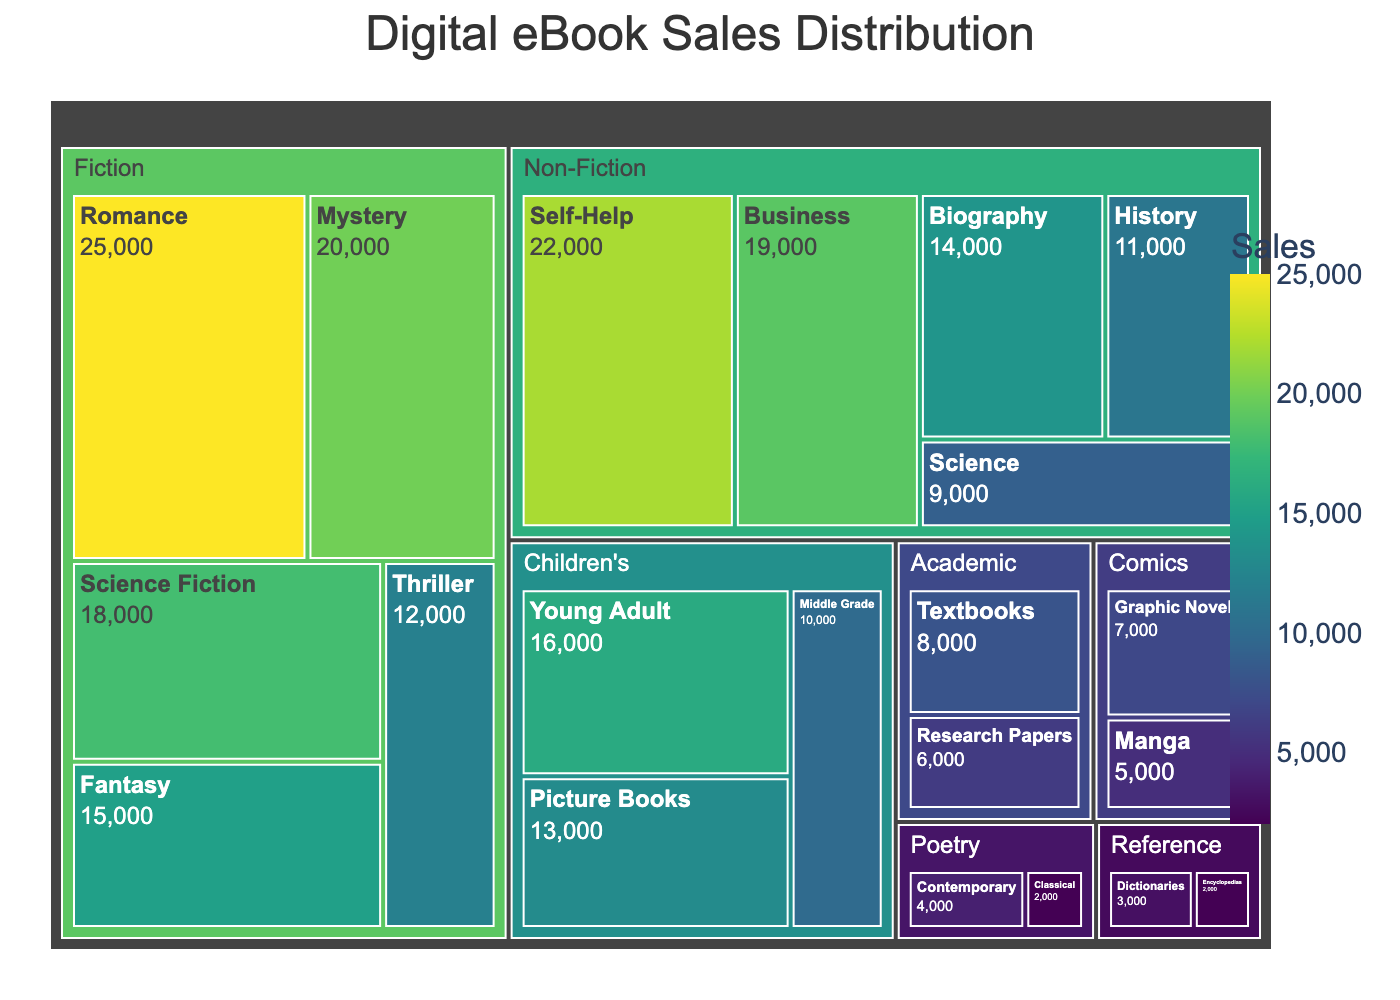What is the title of the treemap? The title is placed at the top center of the treemap, making it easily visible.
Answer: Digital eBook Sales Distribution Which genre has the highest sales in total? To determine this, add up the sales for all categories within each genre. Fiction has the highest total with sales from categories such as Romance (25000), Mystery (20000), and others.
Answer: Fiction How much more did Romance books sell compared to Dictionaries? Subtract the sales of Dictionaries (3000) from Romance (25000) to get the difference.
Answer: 22000 What is the smallest sales value shown in the treemap? The smallest sales value can be found by looking at the categories with the smallest areas: Classical Poetry with 2000 sales.
Answer: 2000 Between Non-Fiction categories of Business and Self-Help, which one has higher sales? Compare the sales values of Business (19000) and Self-Help (22000).
Answer: Self-Help Which category under Children's genre has the highest sales? Examine each category under Children's genre and find the one with the highest sales: Young Adult with 16000.
Answer: Young Adult What is the total sales value for all categories under Non-Fiction? Add up the sales values for all Non-Fiction categories: Self-Help (22000), Business (19000), Biography (14000), History (11000), and Science (9000). 22000 + 19000 + 14000 + 11000 + 9000 = 75000.
Answer: 75000 Are there more Fiction or Non-Fiction categories in the treemap? Count the number of categories listed under each genre. Fiction has 5 categories, while Non-Fiction has 5.
Answer: Equal What are the sales values for all categories under the Academic genre combined? Add the sales values for Textbooks (8000) and Research Papers (6000). 8000 + 6000 = 14000.
Answer: 14000 Which genre has lower total sales, Poetry or Reference? Calculate total sales for each genre: Poetry has Contemporary (4000) and Classical (2000) totaling 6000, Reference has Dictionaries (3000) and Encyclopedias (2000) totaling 5000.
Answer: Reference 